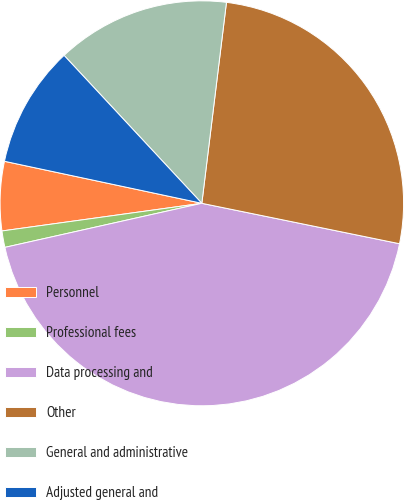<chart> <loc_0><loc_0><loc_500><loc_500><pie_chart><fcel>Personnel<fcel>Professional fees<fcel>Data processing and<fcel>Other<fcel>General and administrative<fcel>Adjusted general and<nl><fcel>5.51%<fcel>1.31%<fcel>43.31%<fcel>26.25%<fcel>13.91%<fcel>9.71%<nl></chart> 